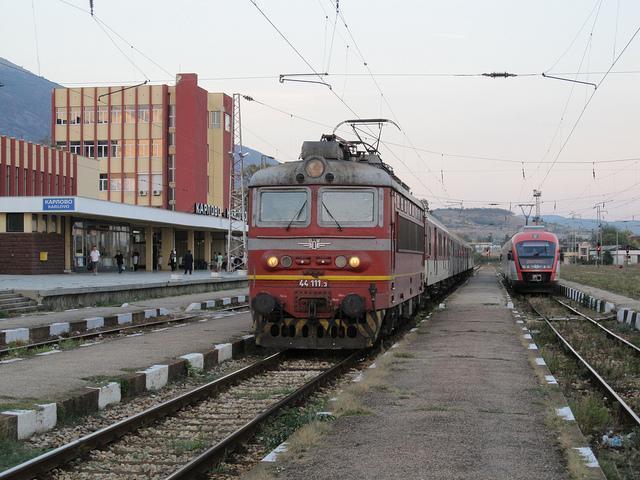How many trains are there?
Give a very brief answer. 2. 